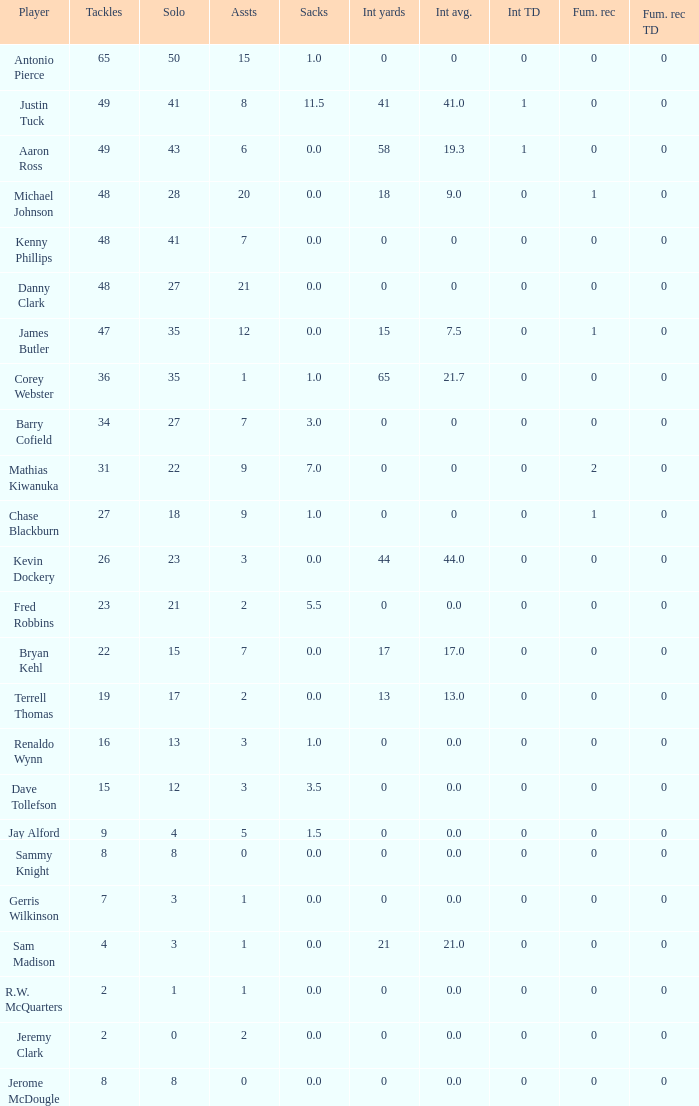What is the sum for the int yards that has an assts more than 3, and player Jay Alford? 0.0. 